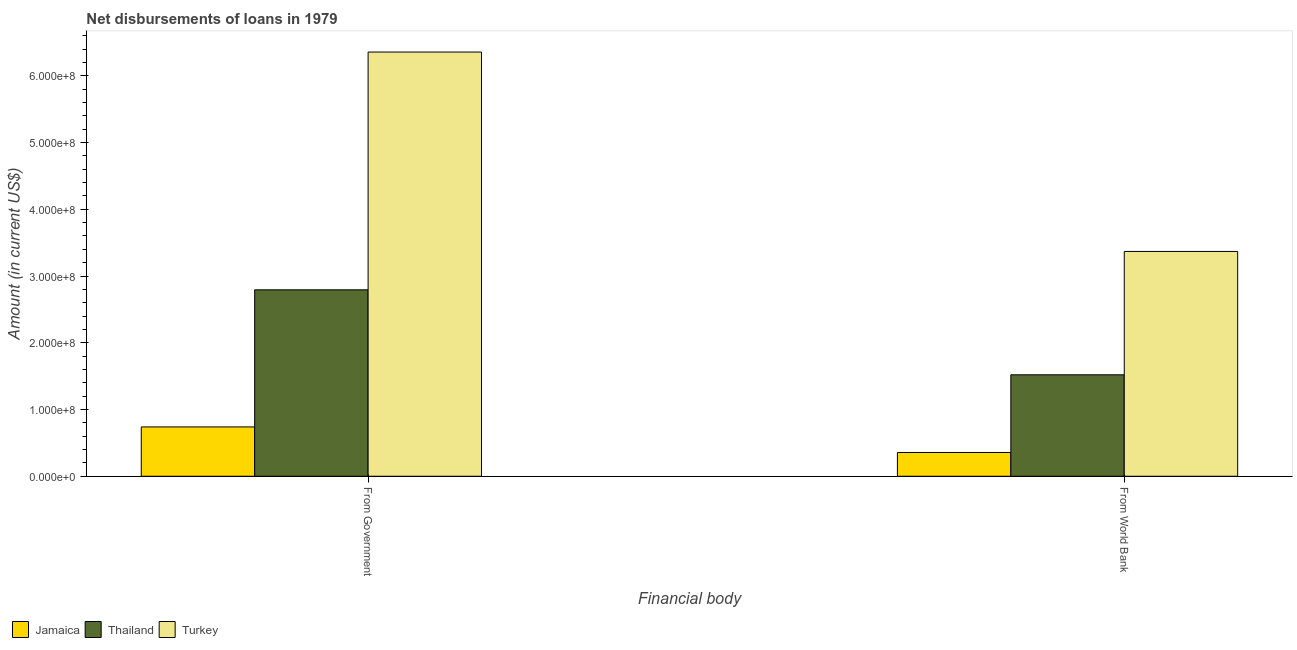Are the number of bars on each tick of the X-axis equal?
Your response must be concise. Yes. How many bars are there on the 1st tick from the left?
Make the answer very short. 3. How many bars are there on the 2nd tick from the right?
Make the answer very short. 3. What is the label of the 1st group of bars from the left?
Make the answer very short. From Government. What is the net disbursements of loan from world bank in Jamaica?
Offer a very short reply. 3.56e+07. Across all countries, what is the maximum net disbursements of loan from government?
Offer a terse response. 6.36e+08. Across all countries, what is the minimum net disbursements of loan from world bank?
Keep it short and to the point. 3.56e+07. In which country was the net disbursements of loan from world bank minimum?
Ensure brevity in your answer.  Jamaica. What is the total net disbursements of loan from world bank in the graph?
Give a very brief answer. 5.24e+08. What is the difference between the net disbursements of loan from world bank in Jamaica and that in Thailand?
Ensure brevity in your answer.  -1.16e+08. What is the difference between the net disbursements of loan from government in Jamaica and the net disbursements of loan from world bank in Turkey?
Provide a succinct answer. -2.63e+08. What is the average net disbursements of loan from world bank per country?
Your answer should be very brief. 1.75e+08. What is the difference between the net disbursements of loan from world bank and net disbursements of loan from government in Jamaica?
Your answer should be very brief. -3.83e+07. What is the ratio of the net disbursements of loan from world bank in Thailand to that in Turkey?
Keep it short and to the point. 0.45. Is the net disbursements of loan from world bank in Turkey less than that in Jamaica?
Your response must be concise. No. What does the 3rd bar from the left in From World Bank represents?
Your answer should be very brief. Turkey. What does the 3rd bar from the right in From World Bank represents?
Offer a very short reply. Jamaica. Are all the bars in the graph horizontal?
Keep it short and to the point. No. How many countries are there in the graph?
Provide a succinct answer. 3. Does the graph contain any zero values?
Offer a terse response. No. Does the graph contain grids?
Keep it short and to the point. No. What is the title of the graph?
Make the answer very short. Net disbursements of loans in 1979. Does "Costa Rica" appear as one of the legend labels in the graph?
Keep it short and to the point. No. What is the label or title of the X-axis?
Your answer should be compact. Financial body. What is the label or title of the Y-axis?
Provide a short and direct response. Amount (in current US$). What is the Amount (in current US$) of Jamaica in From Government?
Give a very brief answer. 7.39e+07. What is the Amount (in current US$) of Thailand in From Government?
Make the answer very short. 2.79e+08. What is the Amount (in current US$) in Turkey in From Government?
Offer a very short reply. 6.36e+08. What is the Amount (in current US$) of Jamaica in From World Bank?
Offer a terse response. 3.56e+07. What is the Amount (in current US$) of Thailand in From World Bank?
Give a very brief answer. 1.52e+08. What is the Amount (in current US$) of Turkey in From World Bank?
Your response must be concise. 3.37e+08. Across all Financial body, what is the maximum Amount (in current US$) in Jamaica?
Your response must be concise. 7.39e+07. Across all Financial body, what is the maximum Amount (in current US$) of Thailand?
Your answer should be very brief. 2.79e+08. Across all Financial body, what is the maximum Amount (in current US$) of Turkey?
Ensure brevity in your answer.  6.36e+08. Across all Financial body, what is the minimum Amount (in current US$) in Jamaica?
Keep it short and to the point. 3.56e+07. Across all Financial body, what is the minimum Amount (in current US$) in Thailand?
Make the answer very short. 1.52e+08. Across all Financial body, what is the minimum Amount (in current US$) in Turkey?
Give a very brief answer. 3.37e+08. What is the total Amount (in current US$) in Jamaica in the graph?
Provide a short and direct response. 1.10e+08. What is the total Amount (in current US$) in Thailand in the graph?
Provide a short and direct response. 4.31e+08. What is the total Amount (in current US$) in Turkey in the graph?
Keep it short and to the point. 9.72e+08. What is the difference between the Amount (in current US$) of Jamaica in From Government and that in From World Bank?
Keep it short and to the point. 3.83e+07. What is the difference between the Amount (in current US$) of Thailand in From Government and that in From World Bank?
Offer a very short reply. 1.27e+08. What is the difference between the Amount (in current US$) in Turkey in From Government and that in From World Bank?
Offer a terse response. 2.99e+08. What is the difference between the Amount (in current US$) in Jamaica in From Government and the Amount (in current US$) in Thailand in From World Bank?
Ensure brevity in your answer.  -7.81e+07. What is the difference between the Amount (in current US$) in Jamaica in From Government and the Amount (in current US$) in Turkey in From World Bank?
Ensure brevity in your answer.  -2.63e+08. What is the difference between the Amount (in current US$) in Thailand in From Government and the Amount (in current US$) in Turkey in From World Bank?
Provide a short and direct response. -5.75e+07. What is the average Amount (in current US$) of Jamaica per Financial body?
Make the answer very short. 5.48e+07. What is the average Amount (in current US$) in Thailand per Financial body?
Give a very brief answer. 2.16e+08. What is the average Amount (in current US$) in Turkey per Financial body?
Ensure brevity in your answer.  4.86e+08. What is the difference between the Amount (in current US$) of Jamaica and Amount (in current US$) of Thailand in From Government?
Your answer should be compact. -2.05e+08. What is the difference between the Amount (in current US$) of Jamaica and Amount (in current US$) of Turkey in From Government?
Your answer should be very brief. -5.62e+08. What is the difference between the Amount (in current US$) in Thailand and Amount (in current US$) in Turkey in From Government?
Keep it short and to the point. -3.56e+08. What is the difference between the Amount (in current US$) in Jamaica and Amount (in current US$) in Thailand in From World Bank?
Provide a short and direct response. -1.16e+08. What is the difference between the Amount (in current US$) of Jamaica and Amount (in current US$) of Turkey in From World Bank?
Give a very brief answer. -3.01e+08. What is the difference between the Amount (in current US$) of Thailand and Amount (in current US$) of Turkey in From World Bank?
Offer a terse response. -1.85e+08. What is the ratio of the Amount (in current US$) in Jamaica in From Government to that in From World Bank?
Offer a terse response. 2.07. What is the ratio of the Amount (in current US$) of Thailand in From Government to that in From World Bank?
Ensure brevity in your answer.  1.84. What is the ratio of the Amount (in current US$) of Turkey in From Government to that in From World Bank?
Your answer should be very brief. 1.89. What is the difference between the highest and the second highest Amount (in current US$) in Jamaica?
Your answer should be compact. 3.83e+07. What is the difference between the highest and the second highest Amount (in current US$) of Thailand?
Provide a succinct answer. 1.27e+08. What is the difference between the highest and the second highest Amount (in current US$) in Turkey?
Offer a very short reply. 2.99e+08. What is the difference between the highest and the lowest Amount (in current US$) of Jamaica?
Provide a short and direct response. 3.83e+07. What is the difference between the highest and the lowest Amount (in current US$) in Thailand?
Provide a succinct answer. 1.27e+08. What is the difference between the highest and the lowest Amount (in current US$) of Turkey?
Give a very brief answer. 2.99e+08. 